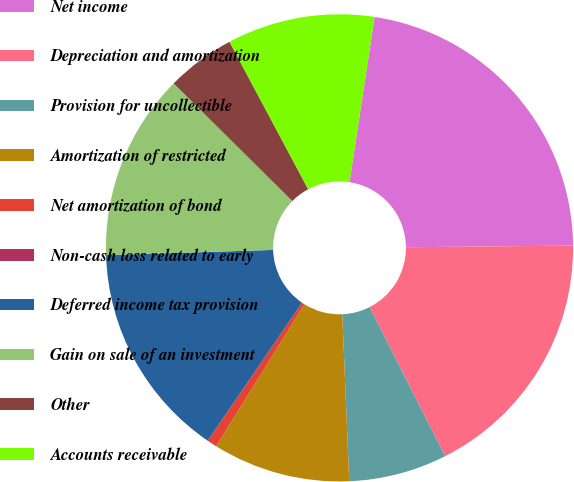Convert chart. <chart><loc_0><loc_0><loc_500><loc_500><pie_chart><fcel>Net income<fcel>Depreciation and amortization<fcel>Provision for uncollectible<fcel>Amortization of restricted<fcel>Net amortization of bond<fcel>Non-cash loss related to early<fcel>Deferred income tax provision<fcel>Gain on sale of an investment<fcel>Other<fcel>Accounts receivable<nl><fcel>22.44%<fcel>17.68%<fcel>6.8%<fcel>9.52%<fcel>0.68%<fcel>0.0%<fcel>14.96%<fcel>12.92%<fcel>4.76%<fcel>10.2%<nl></chart> 